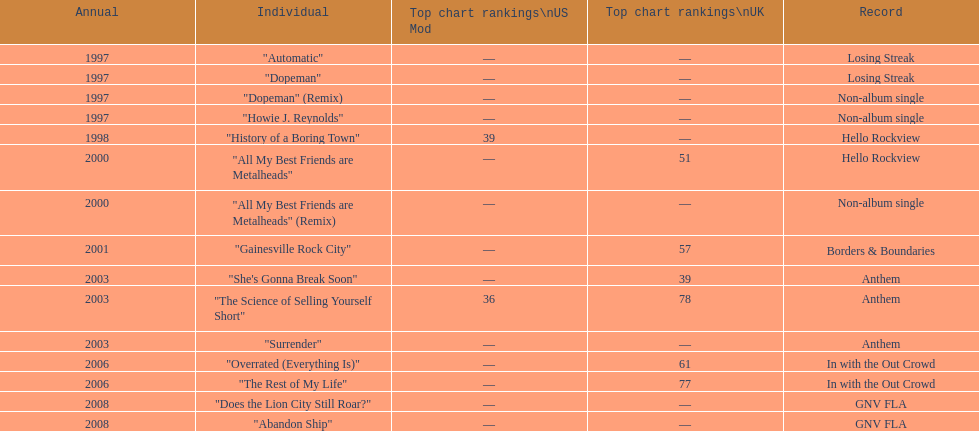Which song came out first? dopeman or surrender. Dopeman. 